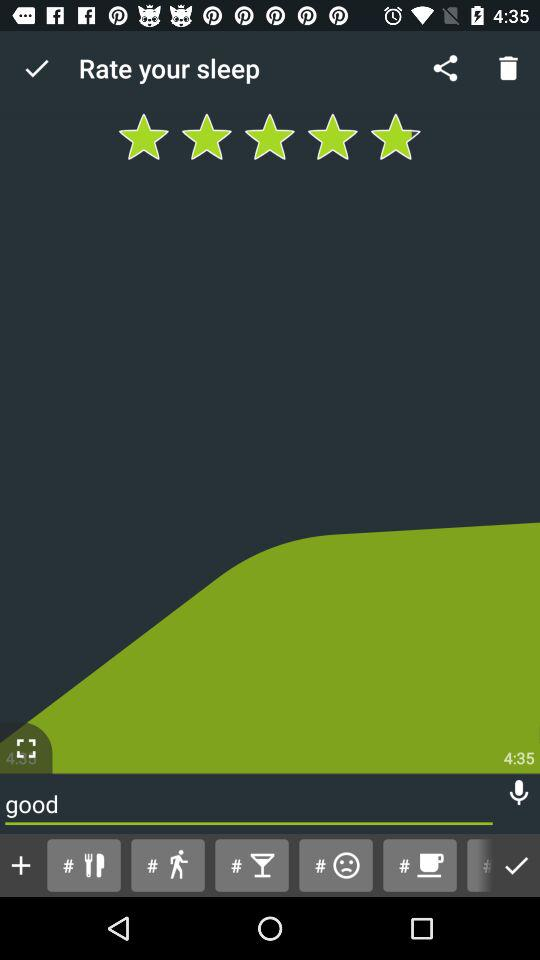What time is displayed on the screen? The displayed time is 4:35. 